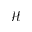Convert formula to latex. <formula><loc_0><loc_0><loc_500><loc_500>\mathcal { H }</formula> 